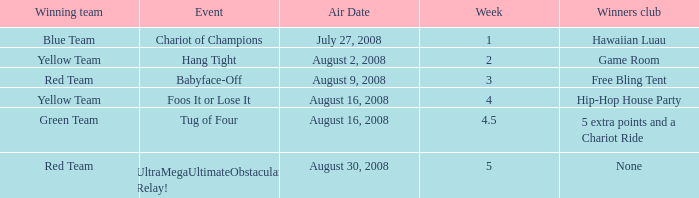Which Winners club has a Week of 4.5? 5 extra points and a Chariot Ride. Help me parse the entirety of this table. {'header': ['Winning team', 'Event', 'Air Date', 'Week', 'Winners club'], 'rows': [['Blue Team', 'Chariot of Champions', 'July 27, 2008', '1', 'Hawaiian Luau'], ['Yellow Team', 'Hang Tight', 'August 2, 2008', '2', 'Game Room'], ['Red Team', 'Babyface-Off', 'August 9, 2008', '3', 'Free Bling Tent'], ['Yellow Team', 'Foos It or Lose It', 'August 16, 2008', '4', 'Hip-Hop House Party'], ['Green Team', 'Tug of Four', 'August 16, 2008', '4.5', '5 extra points and a Chariot Ride'], ['Red Team', 'UltraMegaUltimateObstacular Relay!', 'August 30, 2008', '5', 'None']]} 